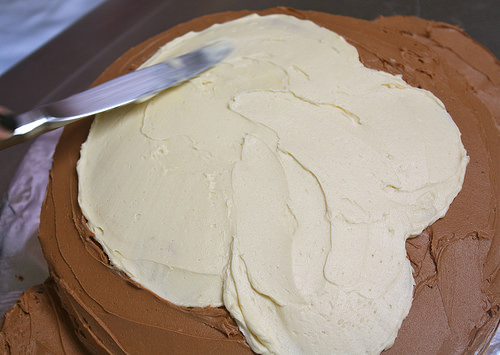<image>
Is the butter knife above the frosting? Yes. The butter knife is positioned above the frosting in the vertical space, higher up in the scene. 